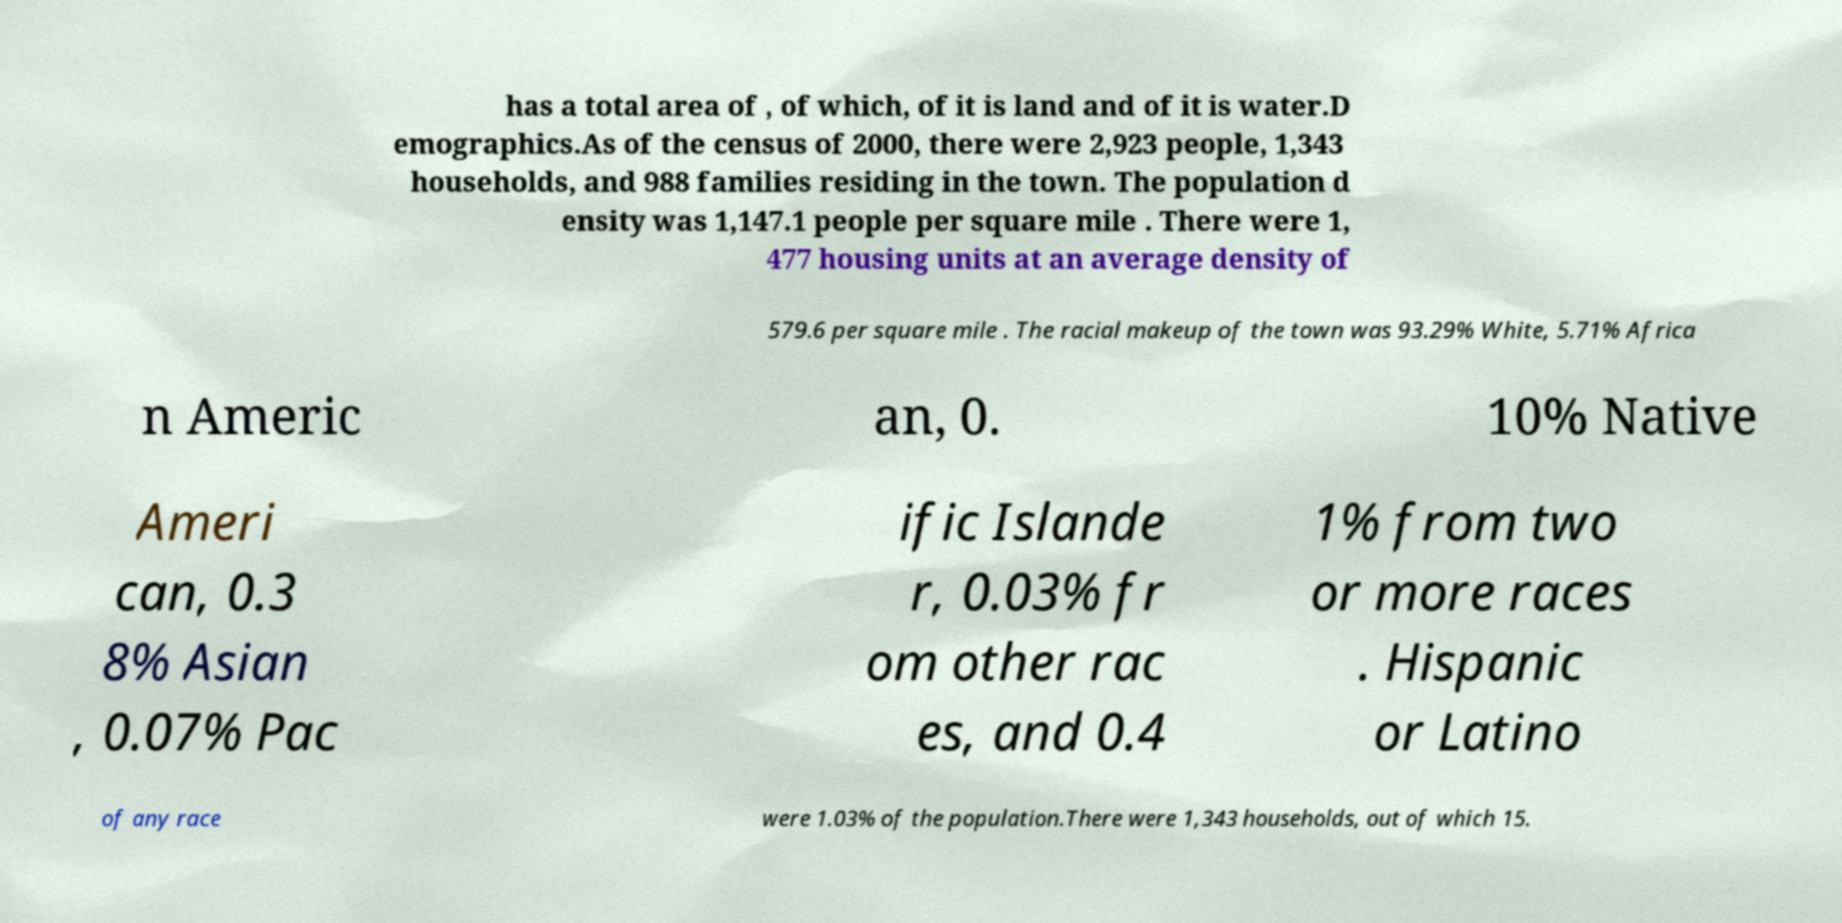Please identify and transcribe the text found in this image. has a total area of , of which, of it is land and of it is water.D emographics.As of the census of 2000, there were 2,923 people, 1,343 households, and 988 families residing in the town. The population d ensity was 1,147.1 people per square mile . There were 1, 477 housing units at an average density of 579.6 per square mile . The racial makeup of the town was 93.29% White, 5.71% Africa n Americ an, 0. 10% Native Ameri can, 0.3 8% Asian , 0.07% Pac ific Islande r, 0.03% fr om other rac es, and 0.4 1% from two or more races . Hispanic or Latino of any race were 1.03% of the population.There were 1,343 households, out of which 15. 